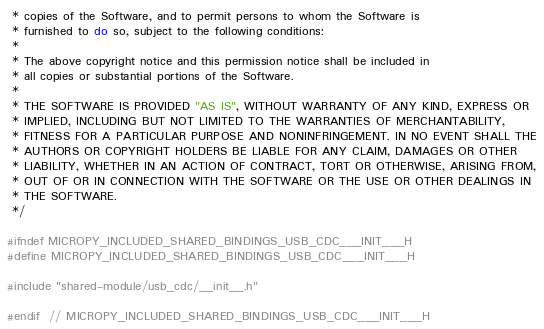<code> <loc_0><loc_0><loc_500><loc_500><_C_> * copies of the Software, and to permit persons to whom the Software is
 * furnished to do so, subject to the following conditions:
 *
 * The above copyright notice and this permission notice shall be included in
 * all copies or substantial portions of the Software.
 *
 * THE SOFTWARE IS PROVIDED "AS IS", WITHOUT WARRANTY OF ANY KIND, EXPRESS OR
 * IMPLIED, INCLUDING BUT NOT LIMITED TO THE WARRANTIES OF MERCHANTABILITY,
 * FITNESS FOR A PARTICULAR PURPOSE AND NONINFRINGEMENT. IN NO EVENT SHALL THE
 * AUTHORS OR COPYRIGHT HOLDERS BE LIABLE FOR ANY CLAIM, DAMAGES OR OTHER
 * LIABILITY, WHETHER IN AN ACTION OF CONTRACT, TORT OR OTHERWISE, ARISING FROM,
 * OUT OF OR IN CONNECTION WITH THE SOFTWARE OR THE USE OR OTHER DEALINGS IN
 * THE SOFTWARE.
 */

#ifndef MICROPY_INCLUDED_SHARED_BINDINGS_USB_CDC___INIT___H
#define MICROPY_INCLUDED_SHARED_BINDINGS_USB_CDC___INIT___H

#include "shared-module/usb_cdc/__init__.h"

#endif  // MICROPY_INCLUDED_SHARED_BINDINGS_USB_CDC___INIT___H
</code> 